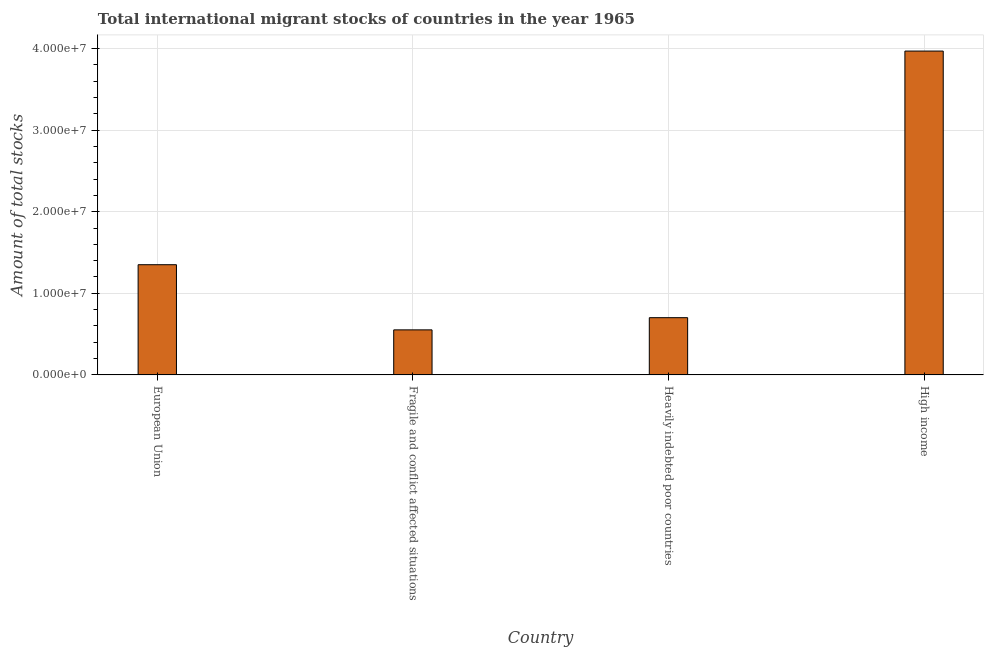Does the graph contain any zero values?
Provide a succinct answer. No. What is the title of the graph?
Your answer should be compact. Total international migrant stocks of countries in the year 1965. What is the label or title of the X-axis?
Offer a very short reply. Country. What is the label or title of the Y-axis?
Provide a succinct answer. Amount of total stocks. What is the total number of international migrant stock in Heavily indebted poor countries?
Your answer should be very brief. 7.01e+06. Across all countries, what is the maximum total number of international migrant stock?
Your answer should be compact. 3.97e+07. Across all countries, what is the minimum total number of international migrant stock?
Your answer should be compact. 5.52e+06. In which country was the total number of international migrant stock maximum?
Keep it short and to the point. High income. In which country was the total number of international migrant stock minimum?
Offer a terse response. Fragile and conflict affected situations. What is the sum of the total number of international migrant stock?
Make the answer very short. 6.57e+07. What is the difference between the total number of international migrant stock in European Union and Fragile and conflict affected situations?
Give a very brief answer. 7.98e+06. What is the average total number of international migrant stock per country?
Provide a short and direct response. 1.64e+07. What is the median total number of international migrant stock?
Provide a succinct answer. 1.03e+07. What is the ratio of the total number of international migrant stock in European Union to that in Fragile and conflict affected situations?
Give a very brief answer. 2.45. What is the difference between the highest and the second highest total number of international migrant stock?
Ensure brevity in your answer.  2.62e+07. Is the sum of the total number of international migrant stock in Fragile and conflict affected situations and High income greater than the maximum total number of international migrant stock across all countries?
Give a very brief answer. Yes. What is the difference between the highest and the lowest total number of international migrant stock?
Make the answer very short. 3.42e+07. Are all the bars in the graph horizontal?
Ensure brevity in your answer.  No. How many countries are there in the graph?
Keep it short and to the point. 4. What is the difference between two consecutive major ticks on the Y-axis?
Keep it short and to the point. 1.00e+07. Are the values on the major ticks of Y-axis written in scientific E-notation?
Your answer should be compact. Yes. What is the Amount of total stocks in European Union?
Make the answer very short. 1.35e+07. What is the Amount of total stocks of Fragile and conflict affected situations?
Give a very brief answer. 5.52e+06. What is the Amount of total stocks of Heavily indebted poor countries?
Make the answer very short. 7.01e+06. What is the Amount of total stocks of High income?
Provide a short and direct response. 3.97e+07. What is the difference between the Amount of total stocks in European Union and Fragile and conflict affected situations?
Provide a succinct answer. 7.98e+06. What is the difference between the Amount of total stocks in European Union and Heavily indebted poor countries?
Provide a succinct answer. 6.49e+06. What is the difference between the Amount of total stocks in European Union and High income?
Give a very brief answer. -2.62e+07. What is the difference between the Amount of total stocks in Fragile and conflict affected situations and Heavily indebted poor countries?
Your answer should be compact. -1.49e+06. What is the difference between the Amount of total stocks in Fragile and conflict affected situations and High income?
Provide a short and direct response. -3.42e+07. What is the difference between the Amount of total stocks in Heavily indebted poor countries and High income?
Offer a terse response. -3.27e+07. What is the ratio of the Amount of total stocks in European Union to that in Fragile and conflict affected situations?
Provide a succinct answer. 2.45. What is the ratio of the Amount of total stocks in European Union to that in Heavily indebted poor countries?
Make the answer very short. 1.93. What is the ratio of the Amount of total stocks in European Union to that in High income?
Keep it short and to the point. 0.34. What is the ratio of the Amount of total stocks in Fragile and conflict affected situations to that in Heavily indebted poor countries?
Provide a succinct answer. 0.79. What is the ratio of the Amount of total stocks in Fragile and conflict affected situations to that in High income?
Your answer should be compact. 0.14. What is the ratio of the Amount of total stocks in Heavily indebted poor countries to that in High income?
Offer a very short reply. 0.18. 